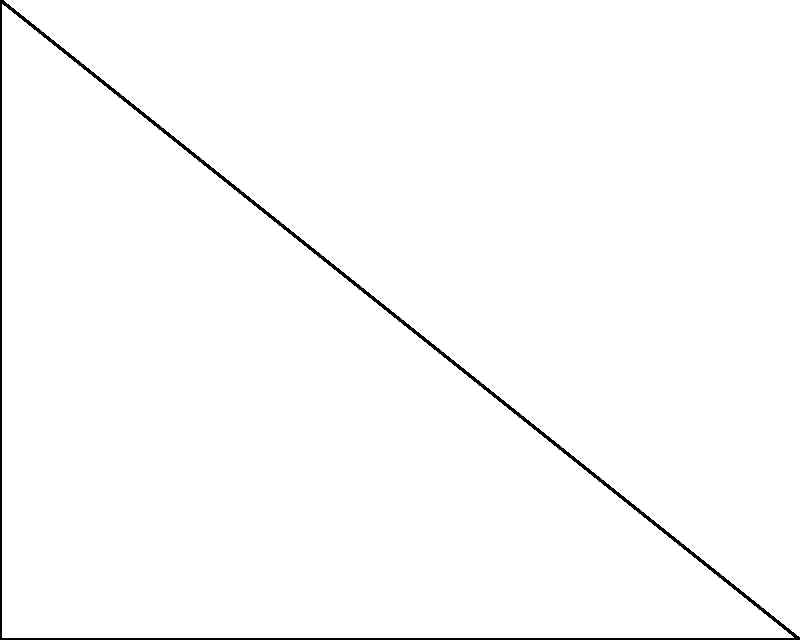Harika bir koşucu olarak, dairesel bir pist tasarlamak istiyorsun. Pist, dik üçgen şeklindeki bir alanın içine yerleştirilecek. Üçgenin kenarları $a$, $b$, ve $c$ (hipotenüs) olarak etiketlenmiştir. Pistin yarıçapı $r$ ile gösterilmektedir. $a = 5$ m, $b = 4$ m ve $c = \sqrt{41}$ m ise, pistin yarıçapını metre cinsinden bulunuz. Bu problemi çözmek için şu adımları izleyelim:

1) Bir dik üçgenin içine çizilen dairenin yarıçapı için formül:

   $$r = \frac{a + b - c}{2}$$

   Burada $a$ ve $b$ dik kenarlar, $c$ ise hipotenüstür.

2) Verilen değerleri formüle yerleştirelim:

   $$r = \frac{5 + 4 - \sqrt{41}}{2}$$

3) Paydadaki işlemleri yapalım:

   $$r = \frac{9 - \sqrt{41}}{2}$$

4) Bu ifadeyi sadeleştiremeyiz, çünkü $\sqrt{41}$ rasyonel bir sayı değildir.

5) Hesap makinesi kullanarak yaklaşık değeri bulabiliriz:

   $$r \approx 1.29$$ m (iki ondalık basamağa yuvarlanmış)

Böylece, pistin yarıçapını bulmuş olduk.
Answer: $\frac{9 - \sqrt{41}}{2}$ m 